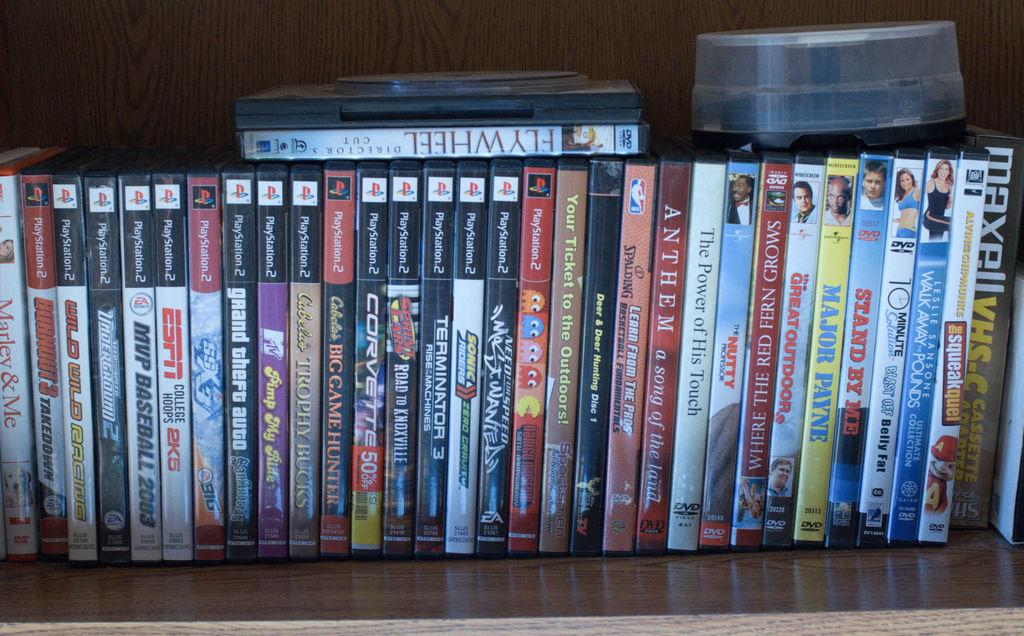What type of items are in the image? There are DVD boxes in the image. Where are the DVD boxes located? The DVD boxes are in a cupboard. What type of material is the lace used for in the image? There is no lace present in the image. Can you see any goldfish swimming in the image? There are no goldfish present in the image. 